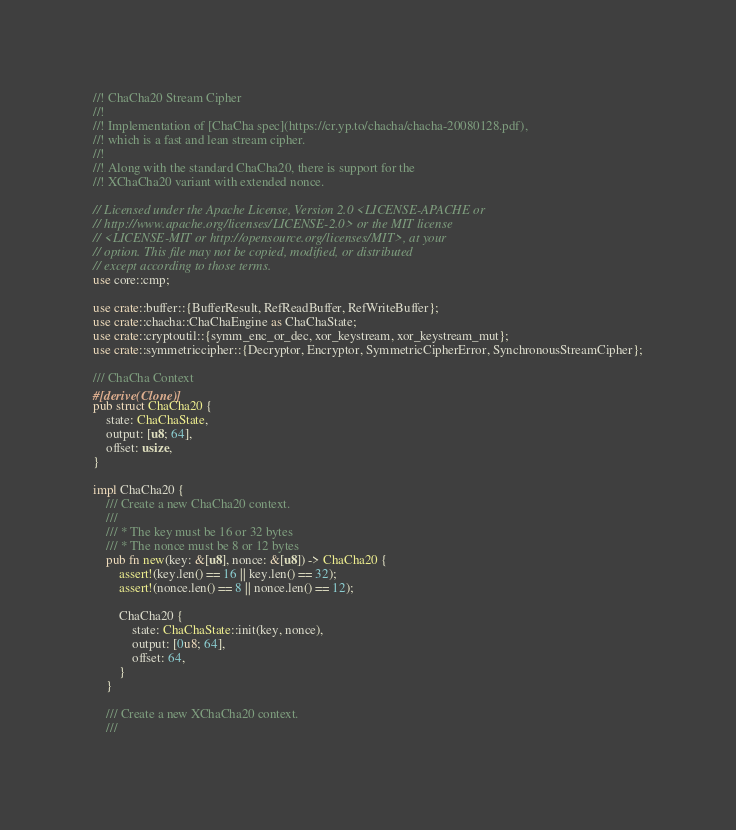<code> <loc_0><loc_0><loc_500><loc_500><_Rust_>//! ChaCha20 Stream Cipher
//!
//! Implementation of [ChaCha spec](https://cr.yp.to/chacha/chacha-20080128.pdf),
//! which is a fast and lean stream cipher.
//!
//! Along with the standard ChaCha20, there is support for the
//! XChaCha20 variant with extended nonce.

// Licensed under the Apache License, Version 2.0 <LICENSE-APACHE or
// http://www.apache.org/licenses/LICENSE-2.0> or the MIT license
// <LICENSE-MIT or http://opensource.org/licenses/MIT>, at your
// option. This file may not be copied, modified, or distributed
// except according to those terms.
use core::cmp;

use crate::buffer::{BufferResult, RefReadBuffer, RefWriteBuffer};
use crate::chacha::ChaChaEngine as ChaChaState;
use crate::cryptoutil::{symm_enc_or_dec, xor_keystream, xor_keystream_mut};
use crate::symmetriccipher::{Decryptor, Encryptor, SymmetricCipherError, SynchronousStreamCipher};

/// ChaCha Context
#[derive(Clone)]
pub struct ChaCha20 {
    state: ChaChaState,
    output: [u8; 64],
    offset: usize,
}

impl ChaCha20 {
    /// Create a new ChaCha20 context.
    ///
    /// * The key must be 16 or 32 bytes
    /// * The nonce must be 8 or 12 bytes
    pub fn new(key: &[u8], nonce: &[u8]) -> ChaCha20 {
        assert!(key.len() == 16 || key.len() == 32);
        assert!(nonce.len() == 8 || nonce.len() == 12);

        ChaCha20 {
            state: ChaChaState::init(key, nonce),
            output: [0u8; 64],
            offset: 64,
        }
    }

    /// Create a new XChaCha20 context.
    ///</code> 